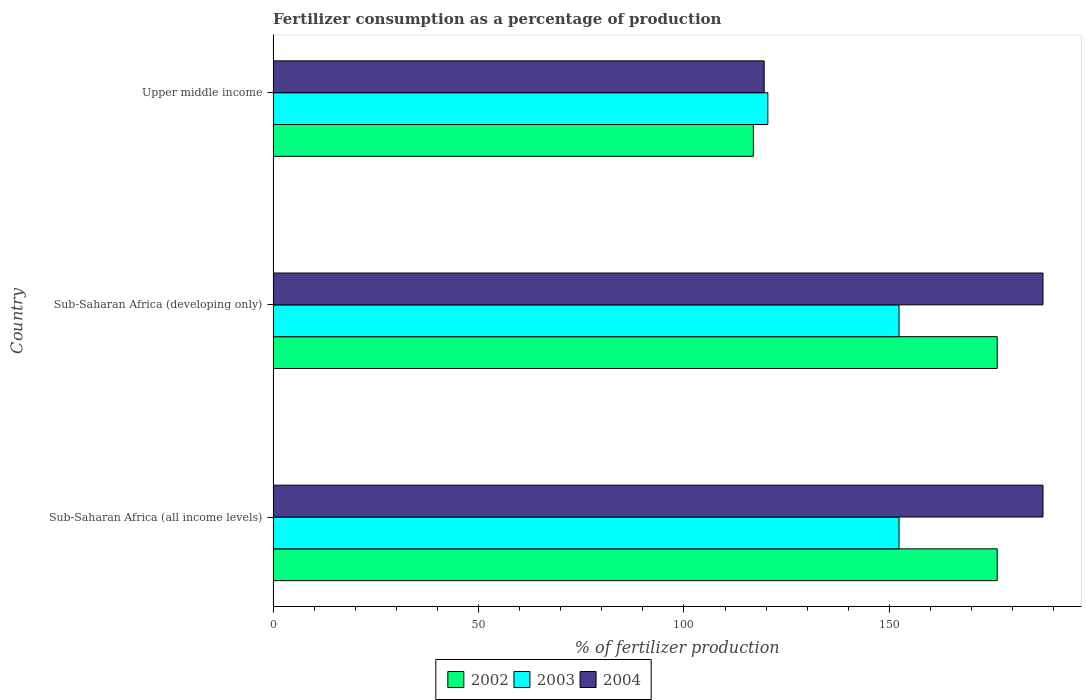How many different coloured bars are there?
Your answer should be very brief. 3. Are the number of bars on each tick of the Y-axis equal?
Ensure brevity in your answer.  Yes. How many bars are there on the 1st tick from the top?
Your answer should be very brief. 3. What is the label of the 2nd group of bars from the top?
Give a very brief answer. Sub-Saharan Africa (developing only). In how many cases, is the number of bars for a given country not equal to the number of legend labels?
Your answer should be compact. 0. What is the percentage of fertilizers consumed in 2002 in Upper middle income?
Provide a succinct answer. 116.9. Across all countries, what is the maximum percentage of fertilizers consumed in 2003?
Keep it short and to the point. 152.35. Across all countries, what is the minimum percentage of fertilizers consumed in 2002?
Make the answer very short. 116.9. In which country was the percentage of fertilizers consumed in 2002 maximum?
Provide a succinct answer. Sub-Saharan Africa (all income levels). In which country was the percentage of fertilizers consumed in 2003 minimum?
Your response must be concise. Upper middle income. What is the total percentage of fertilizers consumed in 2003 in the graph?
Ensure brevity in your answer.  425.13. What is the difference between the percentage of fertilizers consumed in 2002 in Upper middle income and the percentage of fertilizers consumed in 2004 in Sub-Saharan Africa (all income levels)?
Offer a very short reply. -70.5. What is the average percentage of fertilizers consumed in 2004 per country?
Offer a very short reply. 164.77. What is the difference between the percentage of fertilizers consumed in 2004 and percentage of fertilizers consumed in 2002 in Sub-Saharan Africa (developing only)?
Your answer should be compact. 11.14. In how many countries, is the percentage of fertilizers consumed in 2002 greater than 80 %?
Your answer should be compact. 3. What is the ratio of the percentage of fertilizers consumed in 2004 in Sub-Saharan Africa (all income levels) to that in Upper middle income?
Ensure brevity in your answer.  1.57. What is the difference between the highest and the second highest percentage of fertilizers consumed in 2004?
Your answer should be very brief. 0. What is the difference between the highest and the lowest percentage of fertilizers consumed in 2003?
Offer a very short reply. 31.93. In how many countries, is the percentage of fertilizers consumed in 2004 greater than the average percentage of fertilizers consumed in 2004 taken over all countries?
Provide a short and direct response. 2. What does the 1st bar from the top in Upper middle income represents?
Provide a short and direct response. 2004. What does the 3rd bar from the bottom in Sub-Saharan Africa (all income levels) represents?
Give a very brief answer. 2004. Is it the case that in every country, the sum of the percentage of fertilizers consumed in 2003 and percentage of fertilizers consumed in 2002 is greater than the percentage of fertilizers consumed in 2004?
Your answer should be very brief. Yes. Are the values on the major ticks of X-axis written in scientific E-notation?
Your response must be concise. No. Does the graph contain any zero values?
Offer a very short reply. No. Does the graph contain grids?
Your response must be concise. No. Where does the legend appear in the graph?
Your response must be concise. Bottom center. How are the legend labels stacked?
Offer a terse response. Horizontal. What is the title of the graph?
Your response must be concise. Fertilizer consumption as a percentage of production. Does "1970" appear as one of the legend labels in the graph?
Offer a terse response. No. What is the label or title of the X-axis?
Offer a very short reply. % of fertilizer production. What is the % of fertilizer production of 2002 in Sub-Saharan Africa (all income levels)?
Provide a short and direct response. 176.25. What is the % of fertilizer production of 2003 in Sub-Saharan Africa (all income levels)?
Provide a succinct answer. 152.35. What is the % of fertilizer production in 2004 in Sub-Saharan Africa (all income levels)?
Your answer should be very brief. 187.4. What is the % of fertilizer production of 2002 in Sub-Saharan Africa (developing only)?
Offer a very short reply. 176.25. What is the % of fertilizer production in 2003 in Sub-Saharan Africa (developing only)?
Make the answer very short. 152.35. What is the % of fertilizer production of 2004 in Sub-Saharan Africa (developing only)?
Your response must be concise. 187.4. What is the % of fertilizer production in 2002 in Upper middle income?
Ensure brevity in your answer.  116.9. What is the % of fertilizer production of 2003 in Upper middle income?
Give a very brief answer. 120.42. What is the % of fertilizer production of 2004 in Upper middle income?
Your answer should be compact. 119.53. Across all countries, what is the maximum % of fertilizer production in 2002?
Offer a terse response. 176.25. Across all countries, what is the maximum % of fertilizer production of 2003?
Ensure brevity in your answer.  152.35. Across all countries, what is the maximum % of fertilizer production in 2004?
Offer a very short reply. 187.4. Across all countries, what is the minimum % of fertilizer production in 2002?
Your answer should be compact. 116.9. Across all countries, what is the minimum % of fertilizer production of 2003?
Your answer should be very brief. 120.42. Across all countries, what is the minimum % of fertilizer production of 2004?
Keep it short and to the point. 119.53. What is the total % of fertilizer production of 2002 in the graph?
Provide a succinct answer. 469.4. What is the total % of fertilizer production in 2003 in the graph?
Offer a very short reply. 425.13. What is the total % of fertilizer production in 2004 in the graph?
Your response must be concise. 494.32. What is the difference between the % of fertilizer production in 2002 in Sub-Saharan Africa (all income levels) and that in Sub-Saharan Africa (developing only)?
Offer a very short reply. 0. What is the difference between the % of fertilizer production in 2003 in Sub-Saharan Africa (all income levels) and that in Sub-Saharan Africa (developing only)?
Your response must be concise. 0. What is the difference between the % of fertilizer production in 2004 in Sub-Saharan Africa (all income levels) and that in Sub-Saharan Africa (developing only)?
Your answer should be compact. 0. What is the difference between the % of fertilizer production of 2002 in Sub-Saharan Africa (all income levels) and that in Upper middle income?
Your answer should be compact. 59.36. What is the difference between the % of fertilizer production of 2003 in Sub-Saharan Africa (all income levels) and that in Upper middle income?
Your response must be concise. 31.93. What is the difference between the % of fertilizer production in 2004 in Sub-Saharan Africa (all income levels) and that in Upper middle income?
Give a very brief answer. 67.87. What is the difference between the % of fertilizer production in 2002 in Sub-Saharan Africa (developing only) and that in Upper middle income?
Provide a short and direct response. 59.36. What is the difference between the % of fertilizer production of 2003 in Sub-Saharan Africa (developing only) and that in Upper middle income?
Offer a very short reply. 31.93. What is the difference between the % of fertilizer production of 2004 in Sub-Saharan Africa (developing only) and that in Upper middle income?
Your response must be concise. 67.87. What is the difference between the % of fertilizer production of 2002 in Sub-Saharan Africa (all income levels) and the % of fertilizer production of 2003 in Sub-Saharan Africa (developing only)?
Make the answer very short. 23.9. What is the difference between the % of fertilizer production of 2002 in Sub-Saharan Africa (all income levels) and the % of fertilizer production of 2004 in Sub-Saharan Africa (developing only)?
Provide a short and direct response. -11.14. What is the difference between the % of fertilizer production in 2003 in Sub-Saharan Africa (all income levels) and the % of fertilizer production in 2004 in Sub-Saharan Africa (developing only)?
Ensure brevity in your answer.  -35.04. What is the difference between the % of fertilizer production in 2002 in Sub-Saharan Africa (all income levels) and the % of fertilizer production in 2003 in Upper middle income?
Your answer should be compact. 55.83. What is the difference between the % of fertilizer production of 2002 in Sub-Saharan Africa (all income levels) and the % of fertilizer production of 2004 in Upper middle income?
Ensure brevity in your answer.  56.73. What is the difference between the % of fertilizer production in 2003 in Sub-Saharan Africa (all income levels) and the % of fertilizer production in 2004 in Upper middle income?
Provide a short and direct response. 32.82. What is the difference between the % of fertilizer production of 2002 in Sub-Saharan Africa (developing only) and the % of fertilizer production of 2003 in Upper middle income?
Ensure brevity in your answer.  55.83. What is the difference between the % of fertilizer production of 2002 in Sub-Saharan Africa (developing only) and the % of fertilizer production of 2004 in Upper middle income?
Provide a short and direct response. 56.73. What is the difference between the % of fertilizer production in 2003 in Sub-Saharan Africa (developing only) and the % of fertilizer production in 2004 in Upper middle income?
Make the answer very short. 32.82. What is the average % of fertilizer production of 2002 per country?
Make the answer very short. 156.47. What is the average % of fertilizer production of 2003 per country?
Your answer should be very brief. 141.71. What is the average % of fertilizer production of 2004 per country?
Provide a succinct answer. 164.77. What is the difference between the % of fertilizer production of 2002 and % of fertilizer production of 2003 in Sub-Saharan Africa (all income levels)?
Keep it short and to the point. 23.9. What is the difference between the % of fertilizer production in 2002 and % of fertilizer production in 2004 in Sub-Saharan Africa (all income levels)?
Your answer should be compact. -11.14. What is the difference between the % of fertilizer production of 2003 and % of fertilizer production of 2004 in Sub-Saharan Africa (all income levels)?
Provide a succinct answer. -35.04. What is the difference between the % of fertilizer production in 2002 and % of fertilizer production in 2003 in Sub-Saharan Africa (developing only)?
Your answer should be very brief. 23.9. What is the difference between the % of fertilizer production in 2002 and % of fertilizer production in 2004 in Sub-Saharan Africa (developing only)?
Your answer should be very brief. -11.14. What is the difference between the % of fertilizer production of 2003 and % of fertilizer production of 2004 in Sub-Saharan Africa (developing only)?
Make the answer very short. -35.04. What is the difference between the % of fertilizer production of 2002 and % of fertilizer production of 2003 in Upper middle income?
Give a very brief answer. -3.53. What is the difference between the % of fertilizer production in 2002 and % of fertilizer production in 2004 in Upper middle income?
Provide a short and direct response. -2.63. What is the difference between the % of fertilizer production in 2003 and % of fertilizer production in 2004 in Upper middle income?
Your answer should be compact. 0.89. What is the ratio of the % of fertilizer production of 2004 in Sub-Saharan Africa (all income levels) to that in Sub-Saharan Africa (developing only)?
Keep it short and to the point. 1. What is the ratio of the % of fertilizer production of 2002 in Sub-Saharan Africa (all income levels) to that in Upper middle income?
Your answer should be very brief. 1.51. What is the ratio of the % of fertilizer production in 2003 in Sub-Saharan Africa (all income levels) to that in Upper middle income?
Ensure brevity in your answer.  1.27. What is the ratio of the % of fertilizer production in 2004 in Sub-Saharan Africa (all income levels) to that in Upper middle income?
Your answer should be very brief. 1.57. What is the ratio of the % of fertilizer production of 2002 in Sub-Saharan Africa (developing only) to that in Upper middle income?
Offer a terse response. 1.51. What is the ratio of the % of fertilizer production of 2003 in Sub-Saharan Africa (developing only) to that in Upper middle income?
Give a very brief answer. 1.27. What is the ratio of the % of fertilizer production in 2004 in Sub-Saharan Africa (developing only) to that in Upper middle income?
Keep it short and to the point. 1.57. What is the difference between the highest and the second highest % of fertilizer production of 2002?
Give a very brief answer. 0. What is the difference between the highest and the second highest % of fertilizer production of 2004?
Give a very brief answer. 0. What is the difference between the highest and the lowest % of fertilizer production in 2002?
Your answer should be compact. 59.36. What is the difference between the highest and the lowest % of fertilizer production of 2003?
Offer a terse response. 31.93. What is the difference between the highest and the lowest % of fertilizer production of 2004?
Give a very brief answer. 67.87. 